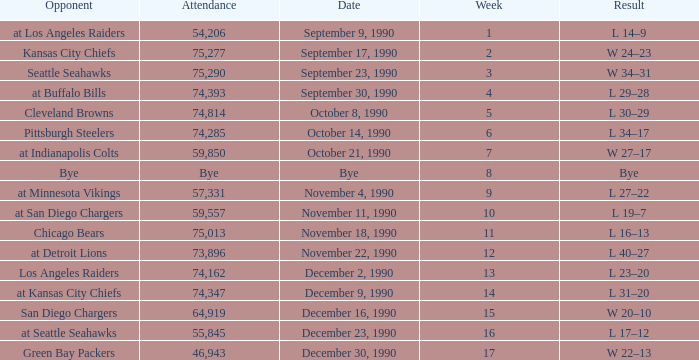Would you mind parsing the complete table? {'header': ['Opponent', 'Attendance', 'Date', 'Week', 'Result'], 'rows': [['at Los Angeles Raiders', '54,206', 'September 9, 1990', '1', 'L 14–9'], ['Kansas City Chiefs', '75,277', 'September 17, 1990', '2', 'W 24–23'], ['Seattle Seahawks', '75,290', 'September 23, 1990', '3', 'W 34–31'], ['at Buffalo Bills', '74,393', 'September 30, 1990', '4', 'L 29–28'], ['Cleveland Browns', '74,814', 'October 8, 1990', '5', 'L 30–29'], ['Pittsburgh Steelers', '74,285', 'October 14, 1990', '6', 'L 34–17'], ['at Indianapolis Colts', '59,850', 'October 21, 1990', '7', 'W 27–17'], ['Bye', 'Bye', 'Bye', '8', 'Bye'], ['at Minnesota Vikings', '57,331', 'November 4, 1990', '9', 'L 27–22'], ['at San Diego Chargers', '59,557', 'November 11, 1990', '10', 'L 19–7'], ['Chicago Bears', '75,013', 'November 18, 1990', '11', 'L 16–13'], ['at Detroit Lions', '73,896', 'November 22, 1990', '12', 'L 40–27'], ['Los Angeles Raiders', '74,162', 'December 2, 1990', '13', 'L 23–20'], ['at Kansas City Chiefs', '74,347', 'December 9, 1990', '14', 'L 31–20'], ['San Diego Chargers', '64,919', 'December 16, 1990', '15', 'W 20–10'], ['at Seattle Seahawks', '55,845', 'December 23, 1990', '16', 'L 17–12'], ['Green Bay Packers', '46,943', 'December 30, 1990', '17', 'W 22–13']]} What day was the attendance 74,285? October 14, 1990. 